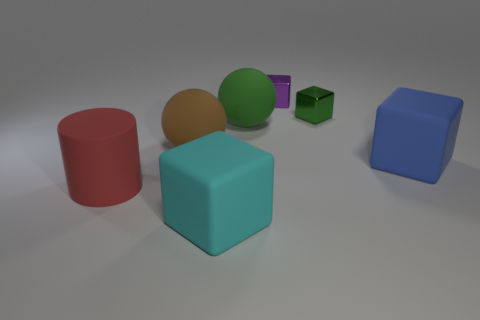How many large matte cylinders are on the left side of the big brown sphere?
Make the answer very short. 1. There is a big matte object on the right side of the tiny cube that is in front of the purple block; what shape is it?
Provide a short and direct response. Cube. There is a blue object that is made of the same material as the red cylinder; what shape is it?
Provide a succinct answer. Cube. Is the size of the purple block behind the green rubber object the same as the rubber thing right of the small green shiny cube?
Your response must be concise. No. There is a object that is to the left of the large brown object; what is its shape?
Make the answer very short. Cylinder. The large cylinder has what color?
Your answer should be compact. Red. There is a cylinder; does it have the same size as the rubber cube in front of the big blue object?
Keep it short and to the point. Yes. What number of metal objects are yellow balls or brown spheres?
Give a very brief answer. 0. Are there any other things that have the same material as the big green object?
Your answer should be compact. Yes. Do the cylinder and the big ball that is to the right of the large brown object have the same color?
Provide a succinct answer. No. 